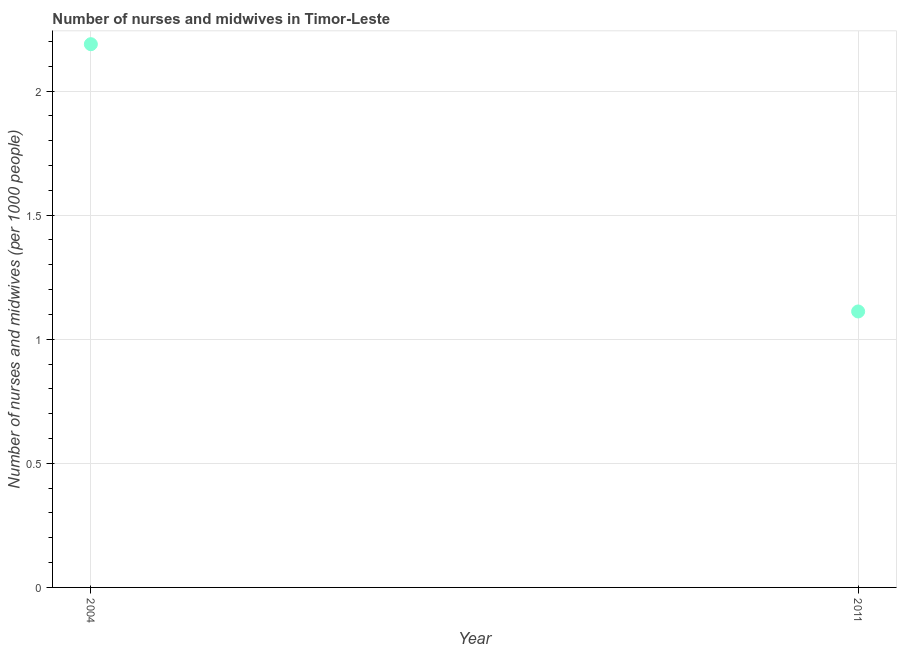What is the number of nurses and midwives in 2004?
Provide a short and direct response. 2.19. Across all years, what is the maximum number of nurses and midwives?
Offer a terse response. 2.19. Across all years, what is the minimum number of nurses and midwives?
Give a very brief answer. 1.11. In which year was the number of nurses and midwives maximum?
Your answer should be very brief. 2004. What is the sum of the number of nurses and midwives?
Your answer should be very brief. 3.3. What is the difference between the number of nurses and midwives in 2004 and 2011?
Provide a succinct answer. 1.08. What is the average number of nurses and midwives per year?
Provide a succinct answer. 1.65. What is the median number of nurses and midwives?
Ensure brevity in your answer.  1.65. In how many years, is the number of nurses and midwives greater than 1.7 ?
Your response must be concise. 1. What is the ratio of the number of nurses and midwives in 2004 to that in 2011?
Offer a terse response. 1.97. How many dotlines are there?
Ensure brevity in your answer.  1. What is the difference between two consecutive major ticks on the Y-axis?
Provide a short and direct response. 0.5. Does the graph contain grids?
Give a very brief answer. Yes. What is the title of the graph?
Ensure brevity in your answer.  Number of nurses and midwives in Timor-Leste. What is the label or title of the Y-axis?
Your answer should be compact. Number of nurses and midwives (per 1000 people). What is the Number of nurses and midwives (per 1000 people) in 2004?
Ensure brevity in your answer.  2.19. What is the Number of nurses and midwives (per 1000 people) in 2011?
Give a very brief answer. 1.11. What is the difference between the Number of nurses and midwives (per 1000 people) in 2004 and 2011?
Your response must be concise. 1.08. What is the ratio of the Number of nurses and midwives (per 1000 people) in 2004 to that in 2011?
Your answer should be compact. 1.97. 